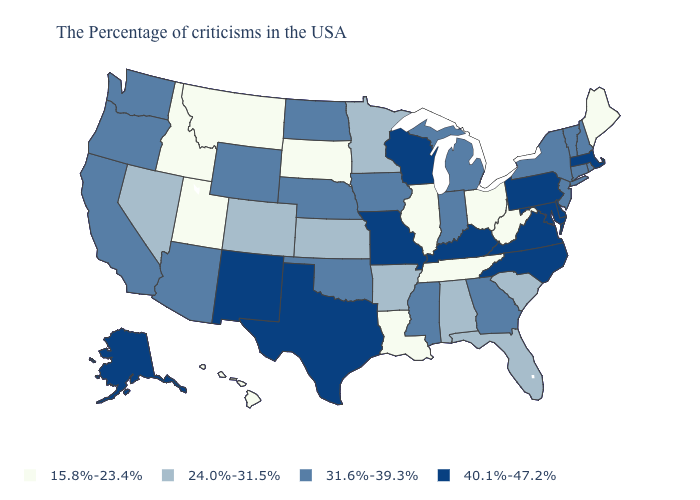Which states have the lowest value in the Northeast?
Concise answer only. Maine. How many symbols are there in the legend?
Short answer required. 4. Name the states that have a value in the range 15.8%-23.4%?
Write a very short answer. Maine, West Virginia, Ohio, Tennessee, Illinois, Louisiana, South Dakota, Utah, Montana, Idaho, Hawaii. Name the states that have a value in the range 24.0%-31.5%?
Quick response, please. South Carolina, Florida, Alabama, Arkansas, Minnesota, Kansas, Colorado, Nevada. Does the map have missing data?
Write a very short answer. No. Among the states that border Kentucky , which have the highest value?
Answer briefly. Virginia, Missouri. Name the states that have a value in the range 24.0%-31.5%?
Keep it brief. South Carolina, Florida, Alabama, Arkansas, Minnesota, Kansas, Colorado, Nevada. Which states have the lowest value in the USA?
Short answer required. Maine, West Virginia, Ohio, Tennessee, Illinois, Louisiana, South Dakota, Utah, Montana, Idaho, Hawaii. What is the value of Kansas?
Give a very brief answer. 24.0%-31.5%. Name the states that have a value in the range 24.0%-31.5%?
Write a very short answer. South Carolina, Florida, Alabama, Arkansas, Minnesota, Kansas, Colorado, Nevada. Name the states that have a value in the range 15.8%-23.4%?
Answer briefly. Maine, West Virginia, Ohio, Tennessee, Illinois, Louisiana, South Dakota, Utah, Montana, Idaho, Hawaii. Among the states that border Arizona , does Utah have the lowest value?
Write a very short answer. Yes. Among the states that border Minnesota , which have the highest value?
Short answer required. Wisconsin. What is the highest value in the South ?
Give a very brief answer. 40.1%-47.2%. Does North Carolina have the highest value in the South?
Quick response, please. Yes. 